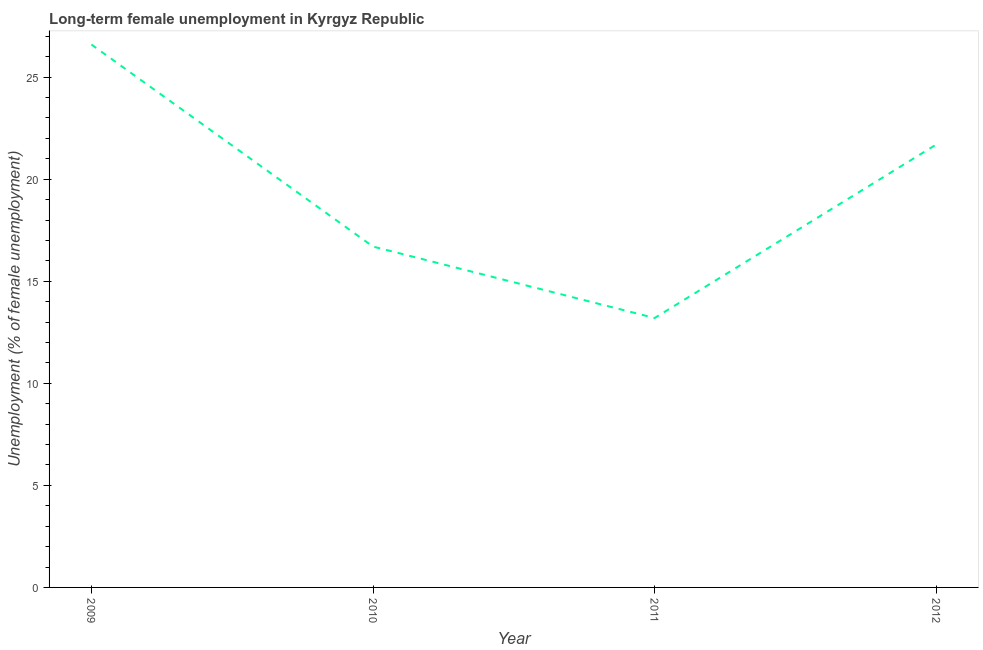What is the long-term female unemployment in 2012?
Provide a short and direct response. 21.7. Across all years, what is the maximum long-term female unemployment?
Give a very brief answer. 26.6. Across all years, what is the minimum long-term female unemployment?
Ensure brevity in your answer.  13.2. In which year was the long-term female unemployment minimum?
Make the answer very short. 2011. What is the sum of the long-term female unemployment?
Keep it short and to the point. 78.2. What is the difference between the long-term female unemployment in 2009 and 2011?
Your answer should be very brief. 13.4. What is the average long-term female unemployment per year?
Ensure brevity in your answer.  19.55. What is the median long-term female unemployment?
Your response must be concise. 19.2. Do a majority of the years between 2009 and 2011 (inclusive) have long-term female unemployment greater than 20 %?
Ensure brevity in your answer.  No. What is the ratio of the long-term female unemployment in 2010 to that in 2012?
Your response must be concise. 0.77. Is the difference between the long-term female unemployment in 2010 and 2011 greater than the difference between any two years?
Your response must be concise. No. What is the difference between the highest and the second highest long-term female unemployment?
Offer a very short reply. 4.9. What is the difference between the highest and the lowest long-term female unemployment?
Your response must be concise. 13.4. In how many years, is the long-term female unemployment greater than the average long-term female unemployment taken over all years?
Offer a very short reply. 2. Does the long-term female unemployment monotonically increase over the years?
Offer a terse response. No. How many lines are there?
Offer a terse response. 1. What is the difference between two consecutive major ticks on the Y-axis?
Provide a succinct answer. 5. Does the graph contain any zero values?
Ensure brevity in your answer.  No. What is the title of the graph?
Offer a very short reply. Long-term female unemployment in Kyrgyz Republic. What is the label or title of the X-axis?
Your answer should be compact. Year. What is the label or title of the Y-axis?
Make the answer very short. Unemployment (% of female unemployment). What is the Unemployment (% of female unemployment) of 2009?
Keep it short and to the point. 26.6. What is the Unemployment (% of female unemployment) of 2010?
Offer a very short reply. 16.7. What is the Unemployment (% of female unemployment) of 2011?
Keep it short and to the point. 13.2. What is the Unemployment (% of female unemployment) in 2012?
Keep it short and to the point. 21.7. What is the difference between the Unemployment (% of female unemployment) in 2010 and 2012?
Keep it short and to the point. -5. What is the ratio of the Unemployment (% of female unemployment) in 2009 to that in 2010?
Your answer should be compact. 1.59. What is the ratio of the Unemployment (% of female unemployment) in 2009 to that in 2011?
Offer a terse response. 2.02. What is the ratio of the Unemployment (% of female unemployment) in 2009 to that in 2012?
Your response must be concise. 1.23. What is the ratio of the Unemployment (% of female unemployment) in 2010 to that in 2011?
Make the answer very short. 1.26. What is the ratio of the Unemployment (% of female unemployment) in 2010 to that in 2012?
Your answer should be very brief. 0.77. What is the ratio of the Unemployment (% of female unemployment) in 2011 to that in 2012?
Provide a succinct answer. 0.61. 